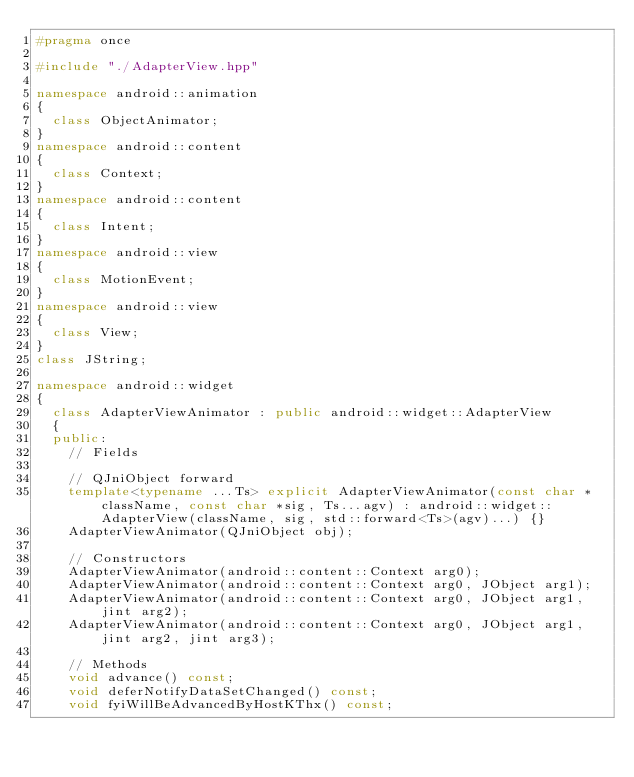Convert code to text. <code><loc_0><loc_0><loc_500><loc_500><_C++_>#pragma once

#include "./AdapterView.hpp"

namespace android::animation
{
	class ObjectAnimator;
}
namespace android::content
{
	class Context;
}
namespace android::content
{
	class Intent;
}
namespace android::view
{
	class MotionEvent;
}
namespace android::view
{
	class View;
}
class JString;

namespace android::widget
{
	class AdapterViewAnimator : public android::widget::AdapterView
	{
	public:
		// Fields
		
		// QJniObject forward
		template<typename ...Ts> explicit AdapterViewAnimator(const char *className, const char *sig, Ts...agv) : android::widget::AdapterView(className, sig, std::forward<Ts>(agv)...) {}
		AdapterViewAnimator(QJniObject obj);
		
		// Constructors
		AdapterViewAnimator(android::content::Context arg0);
		AdapterViewAnimator(android::content::Context arg0, JObject arg1);
		AdapterViewAnimator(android::content::Context arg0, JObject arg1, jint arg2);
		AdapterViewAnimator(android::content::Context arg0, JObject arg1, jint arg2, jint arg3);
		
		// Methods
		void advance() const;
		void deferNotifyDataSetChanged() const;
		void fyiWillBeAdvancedByHostKThx() const;</code> 